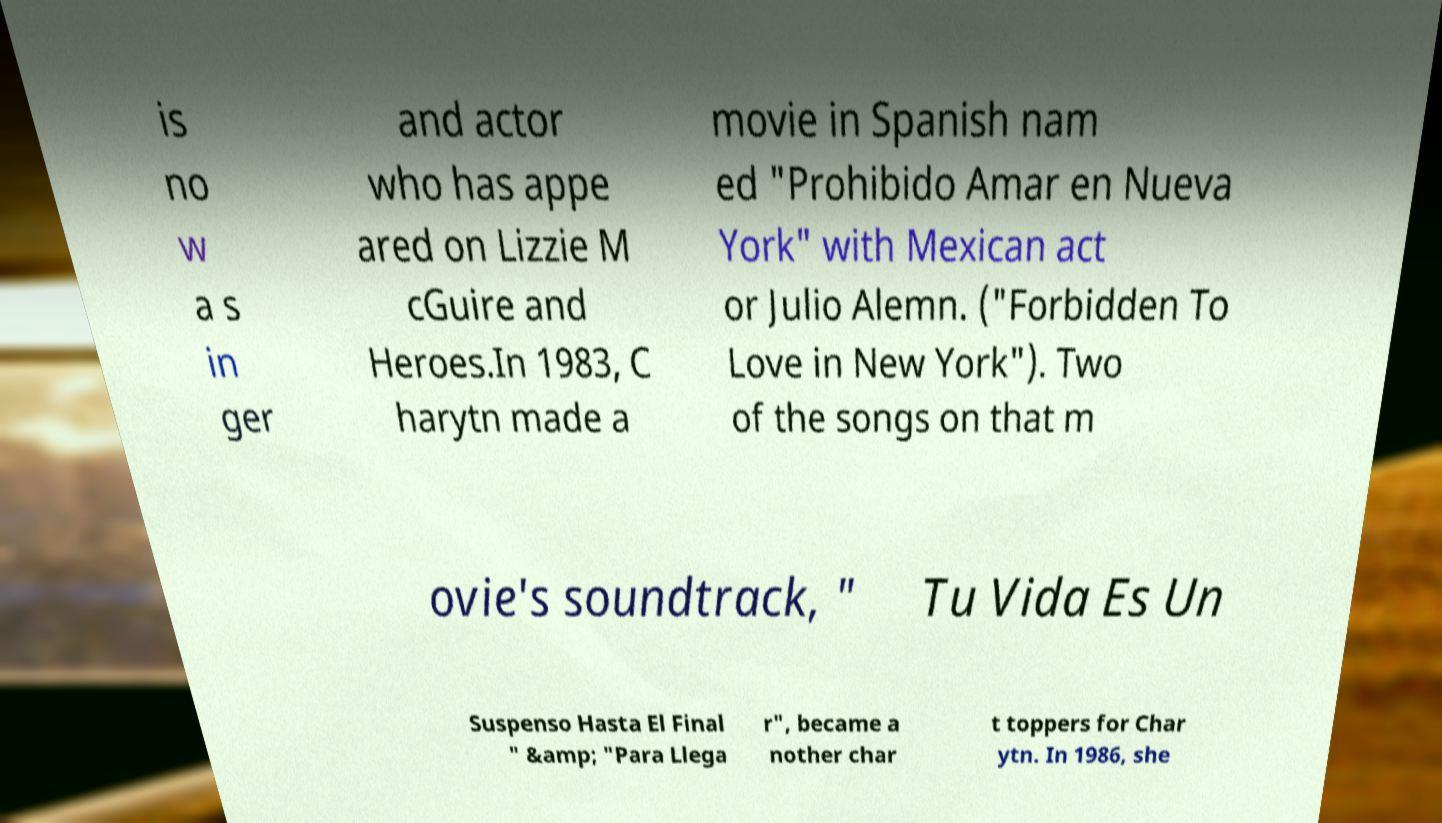Can you accurately transcribe the text from the provided image for me? is no w a s in ger and actor who has appe ared on Lizzie M cGuire and Heroes.In 1983, C harytn made a movie in Spanish nam ed "Prohibido Amar en Nueva York" with Mexican act or Julio Alemn. ("Forbidden To Love in New York"). Two of the songs on that m ovie's soundtrack, " Tu Vida Es Un Suspenso Hasta El Final " &amp; "Para Llega r", became a nother char t toppers for Char ytn. In 1986, she 